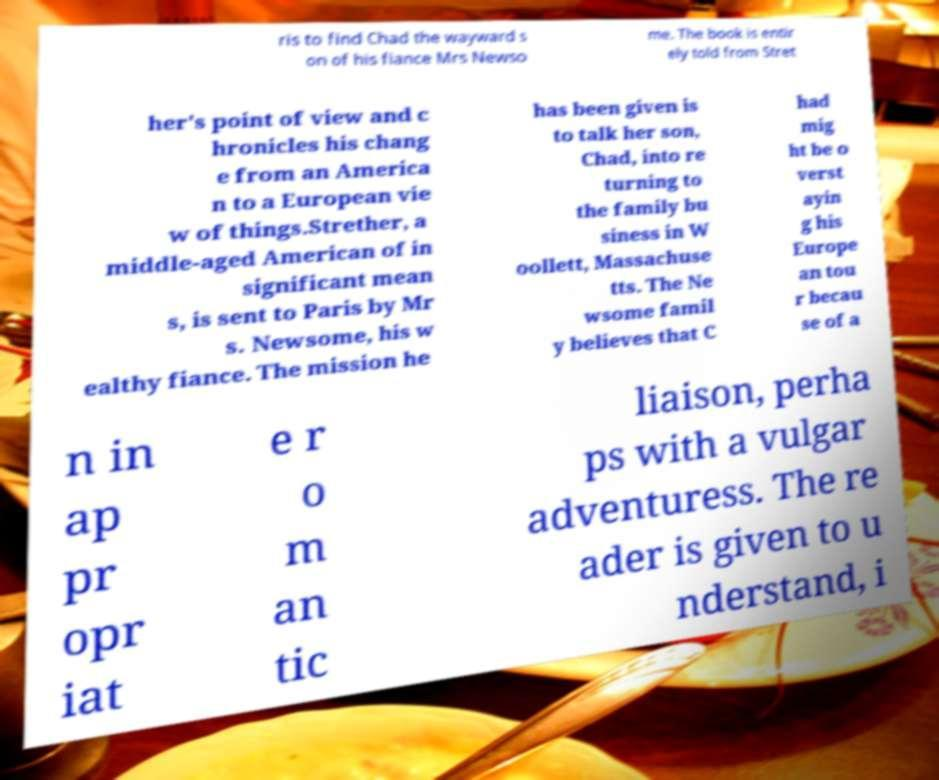What messages or text are displayed in this image? I need them in a readable, typed format. ris to find Chad the wayward s on of his fiance Mrs Newso me. The book is entir ely told from Stret her's point of view and c hronicles his chang e from an America n to a European vie w of things.Strether, a middle-aged American of in significant mean s, is sent to Paris by Mr s. Newsome, his w ealthy fiance. The mission he has been given is to talk her son, Chad, into re turning to the family bu siness in W oollett, Massachuse tts. The Ne wsome famil y believes that C had mig ht be o verst ayin g his Europe an tou r becau se of a n in ap pr opr iat e r o m an tic liaison, perha ps with a vulgar adventuress. The re ader is given to u nderstand, i 